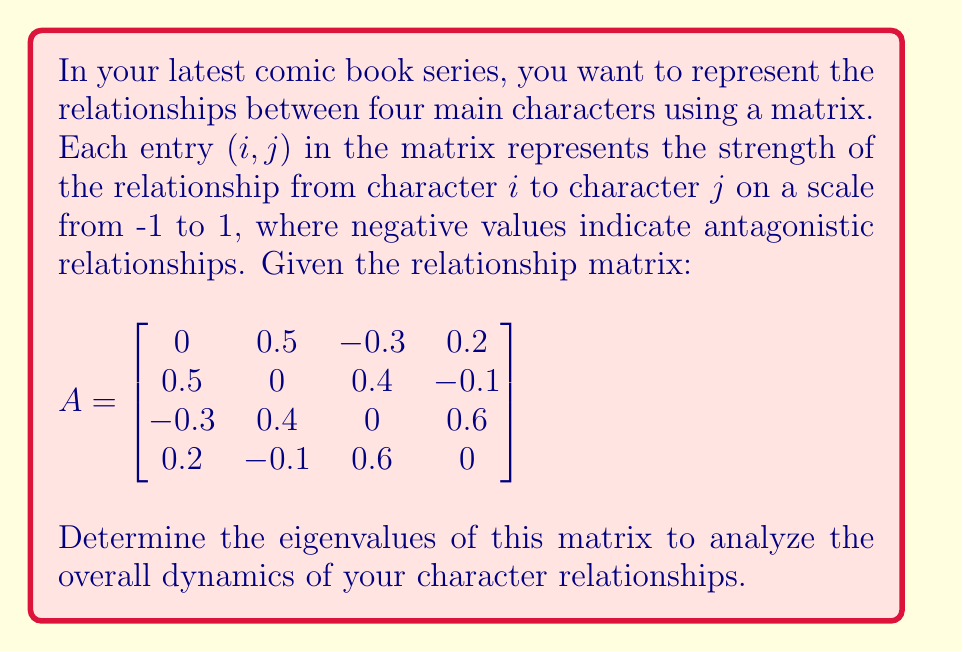Could you help me with this problem? To find the eigenvalues of matrix $A$, we need to solve the characteristic equation:

$\det(A - \lambda I) = 0$

where $\lambda$ represents the eigenvalues and $I$ is the $4 \times 4$ identity matrix.

Step 1: Set up the characteristic equation:
$$\det\begin{bmatrix}
-\lambda & 0.5 & -0.3 & 0.2 \\
0.5 & -\lambda & 0.4 & -0.1 \\
-0.3 & 0.4 & -\lambda & 0.6 \\
0.2 & -0.1 & 0.6 & -\lambda
\end{bmatrix} = 0$$

Step 2: Calculate the determinant. This is a complex process for a 4x4 matrix, so we'll use the fact that the characteristic polynomial of this matrix is:

$\lambda^4 + 0.11\lambda^2 - 0.5776 = 0$

Step 3: Solve this equation. We can factor it as:

$(\lambda^2 + 0.76)(\lambda^2 - 0.65) = 0$

Step 4: Solve each quadratic factor:

$\lambda^2 + 0.76 = 0$ gives $\lambda = \pm i\sqrt{0.76} = \pm 0.8718i$

$\lambda^2 - 0.65 = 0$ gives $\lambda = \pm \sqrt{0.65} = \pm 0.8062$

Therefore, the four eigenvalues are: $0.8062, -0.8062, 0.8718i, -0.8718i$.
Answer: $\lambda_1 = 0.8062, \lambda_2 = -0.8062, \lambda_3 = 0.8718i, \lambda_4 = -0.8718i$ 